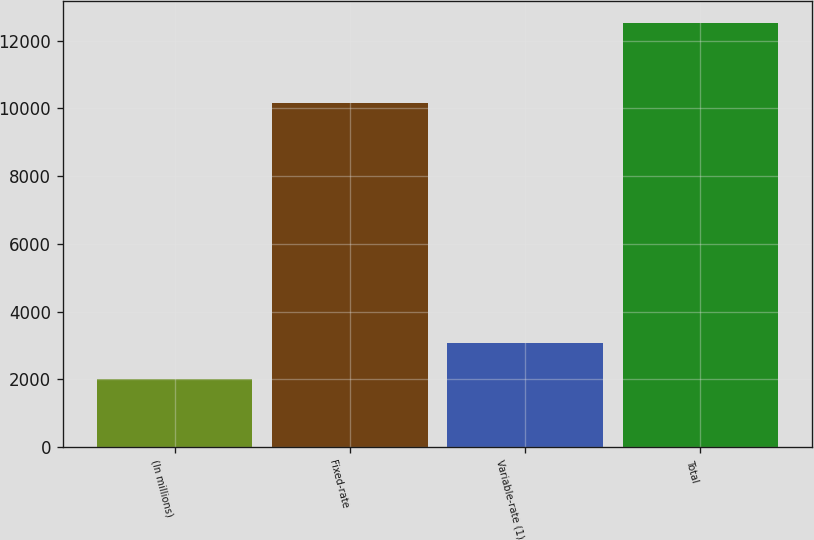<chart> <loc_0><loc_0><loc_500><loc_500><bar_chart><fcel>(In millions)<fcel>Fixed-rate<fcel>Variable-rate (1)<fcel>Total<nl><fcel>2019<fcel>10153.2<fcel>3070.64<fcel>12535.4<nl></chart> 